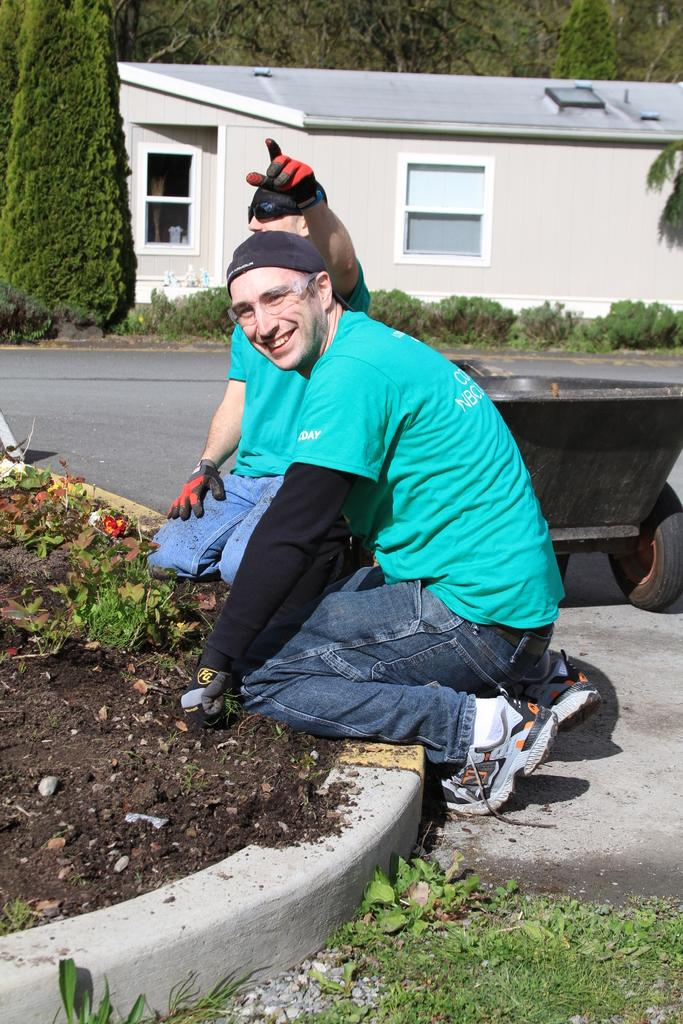How many people are sitting in the image? There are two people sitting in the image. What object can be seen in the image that is typically used for transporting items? There is a trolley in the image. What type of vegetation is present in the image? There are plants and trees in the image. What type of structure is visible in the image? There is a house with a window in the image. What type of pathway is visible in the image? There is a road in the image. What type of thread is being used by the grandfather to play with the children in the image? There is no grandfather or children present in the image, and therefore no such activity can be observed. 